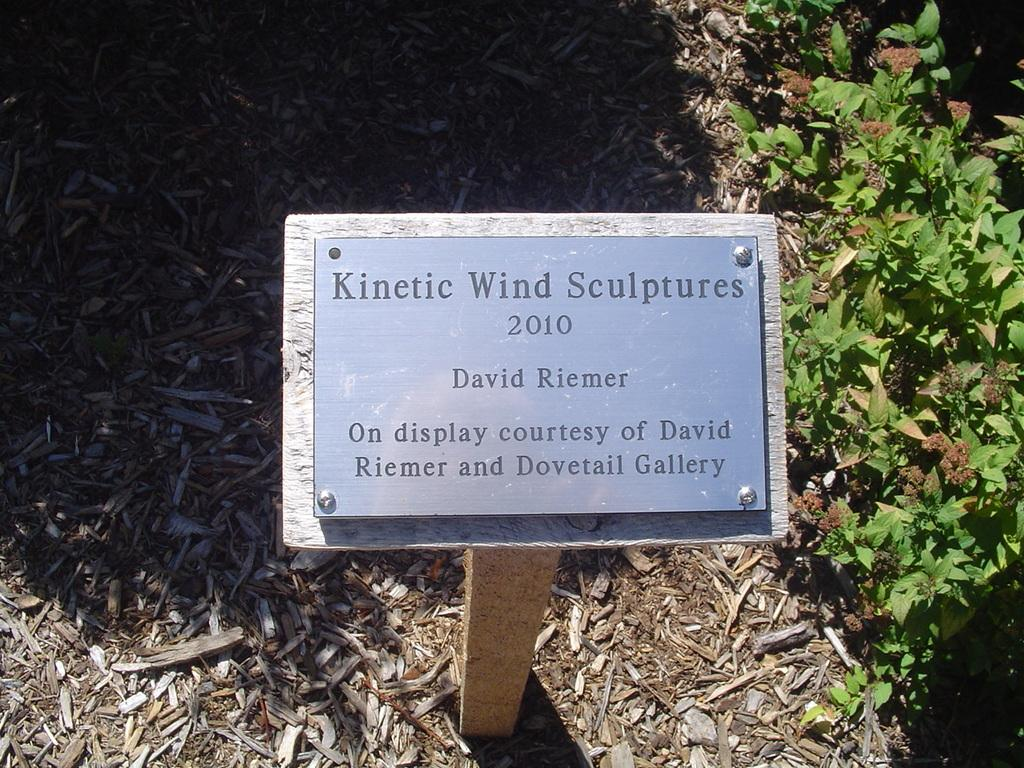What is the main object on the wooden stand in the image? There is a sign board on a wooden stand in the image. What type of plant can be seen in the image? There is a plant in the image. What are the small wooden sticks used for in the image? The purpose of the small wooden sticks is not explicitly mentioned in the facts, but they could be used for supporting the plant or as part of the sign board's design. Can you see a zipper on the plant in the image? No, there is no zipper present on the plant in the image. Is there a kitten playing with the wooden sticks in the image? No, there is no kitten present in the image. 